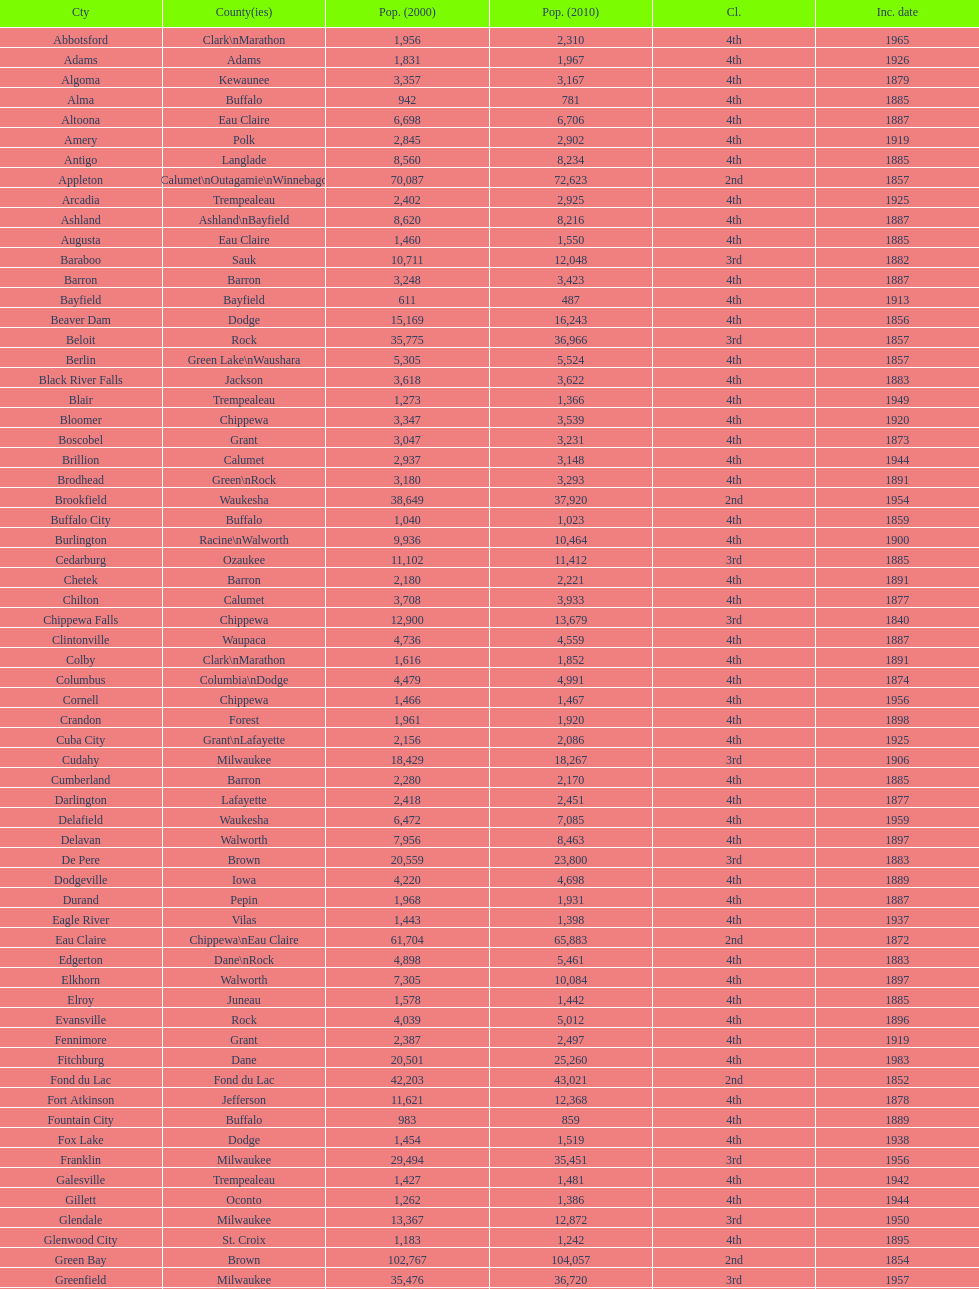Could you parse the entire table? {'header': ['Cty', 'County(ies)', 'Pop. (2000)', 'Pop. (2010)', 'Cl.', 'Inc. date'], 'rows': [['Abbotsford', 'Clark\\nMarathon', '1,956', '2,310', '4th', '1965'], ['Adams', 'Adams', '1,831', '1,967', '4th', '1926'], ['Algoma', 'Kewaunee', '3,357', '3,167', '4th', '1879'], ['Alma', 'Buffalo', '942', '781', '4th', '1885'], ['Altoona', 'Eau Claire', '6,698', '6,706', '4th', '1887'], ['Amery', 'Polk', '2,845', '2,902', '4th', '1919'], ['Antigo', 'Langlade', '8,560', '8,234', '4th', '1885'], ['Appleton', 'Calumet\\nOutagamie\\nWinnebago', '70,087', '72,623', '2nd', '1857'], ['Arcadia', 'Trempealeau', '2,402', '2,925', '4th', '1925'], ['Ashland', 'Ashland\\nBayfield', '8,620', '8,216', '4th', '1887'], ['Augusta', 'Eau Claire', '1,460', '1,550', '4th', '1885'], ['Baraboo', 'Sauk', '10,711', '12,048', '3rd', '1882'], ['Barron', 'Barron', '3,248', '3,423', '4th', '1887'], ['Bayfield', 'Bayfield', '611', '487', '4th', '1913'], ['Beaver Dam', 'Dodge', '15,169', '16,243', '4th', '1856'], ['Beloit', 'Rock', '35,775', '36,966', '3rd', '1857'], ['Berlin', 'Green Lake\\nWaushara', '5,305', '5,524', '4th', '1857'], ['Black River Falls', 'Jackson', '3,618', '3,622', '4th', '1883'], ['Blair', 'Trempealeau', '1,273', '1,366', '4th', '1949'], ['Bloomer', 'Chippewa', '3,347', '3,539', '4th', '1920'], ['Boscobel', 'Grant', '3,047', '3,231', '4th', '1873'], ['Brillion', 'Calumet', '2,937', '3,148', '4th', '1944'], ['Brodhead', 'Green\\nRock', '3,180', '3,293', '4th', '1891'], ['Brookfield', 'Waukesha', '38,649', '37,920', '2nd', '1954'], ['Buffalo City', 'Buffalo', '1,040', '1,023', '4th', '1859'], ['Burlington', 'Racine\\nWalworth', '9,936', '10,464', '4th', '1900'], ['Cedarburg', 'Ozaukee', '11,102', '11,412', '3rd', '1885'], ['Chetek', 'Barron', '2,180', '2,221', '4th', '1891'], ['Chilton', 'Calumet', '3,708', '3,933', '4th', '1877'], ['Chippewa Falls', 'Chippewa', '12,900', '13,679', '3rd', '1840'], ['Clintonville', 'Waupaca', '4,736', '4,559', '4th', '1887'], ['Colby', 'Clark\\nMarathon', '1,616', '1,852', '4th', '1891'], ['Columbus', 'Columbia\\nDodge', '4,479', '4,991', '4th', '1874'], ['Cornell', 'Chippewa', '1,466', '1,467', '4th', '1956'], ['Crandon', 'Forest', '1,961', '1,920', '4th', '1898'], ['Cuba City', 'Grant\\nLafayette', '2,156', '2,086', '4th', '1925'], ['Cudahy', 'Milwaukee', '18,429', '18,267', '3rd', '1906'], ['Cumberland', 'Barron', '2,280', '2,170', '4th', '1885'], ['Darlington', 'Lafayette', '2,418', '2,451', '4th', '1877'], ['Delafield', 'Waukesha', '6,472', '7,085', '4th', '1959'], ['Delavan', 'Walworth', '7,956', '8,463', '4th', '1897'], ['De Pere', 'Brown', '20,559', '23,800', '3rd', '1883'], ['Dodgeville', 'Iowa', '4,220', '4,698', '4th', '1889'], ['Durand', 'Pepin', '1,968', '1,931', '4th', '1887'], ['Eagle River', 'Vilas', '1,443', '1,398', '4th', '1937'], ['Eau Claire', 'Chippewa\\nEau Claire', '61,704', '65,883', '2nd', '1872'], ['Edgerton', 'Dane\\nRock', '4,898', '5,461', '4th', '1883'], ['Elkhorn', 'Walworth', '7,305', '10,084', '4th', '1897'], ['Elroy', 'Juneau', '1,578', '1,442', '4th', '1885'], ['Evansville', 'Rock', '4,039', '5,012', '4th', '1896'], ['Fennimore', 'Grant', '2,387', '2,497', '4th', '1919'], ['Fitchburg', 'Dane', '20,501', '25,260', '4th', '1983'], ['Fond du Lac', 'Fond du Lac', '42,203', '43,021', '2nd', '1852'], ['Fort Atkinson', 'Jefferson', '11,621', '12,368', '4th', '1878'], ['Fountain City', 'Buffalo', '983', '859', '4th', '1889'], ['Fox Lake', 'Dodge', '1,454', '1,519', '4th', '1938'], ['Franklin', 'Milwaukee', '29,494', '35,451', '3rd', '1956'], ['Galesville', 'Trempealeau', '1,427', '1,481', '4th', '1942'], ['Gillett', 'Oconto', '1,262', '1,386', '4th', '1944'], ['Glendale', 'Milwaukee', '13,367', '12,872', '3rd', '1950'], ['Glenwood City', 'St. Croix', '1,183', '1,242', '4th', '1895'], ['Green Bay', 'Brown', '102,767', '104,057', '2nd', '1854'], ['Greenfield', 'Milwaukee', '35,476', '36,720', '3rd', '1957'], ['Green Lake', 'Green Lake', '1,100', '960', '4th', '1962'], ['Greenwood', 'Clark', '1,079', '1,026', '4th', '1891'], ['Hartford', 'Dodge\\nWashington', '10,905', '14,223', '3rd', '1883'], ['Hayward', 'Sawyer', '2,129', '2,318', '4th', '1915'], ['Hillsboro', 'Vernon', '1,302', '1,417', '4th', '1885'], ['Horicon', 'Dodge', '3,775', '3,655', '4th', '1897'], ['Hudson', 'St. Croix', '8,775', '12,719', '4th', '1858'], ['Hurley', 'Iron', '1,818', '1,547', '4th', '1918'], ['Independence', 'Trempealeau', '1,244', '1,336', '4th', '1942'], ['Janesville', 'Rock', '59,498', '63,575', '2nd', '1853'], ['Jefferson', 'Jefferson', '7,338', '7,973', '4th', '1878'], ['Juneau', 'Dodge', '2,485', '2,814', '4th', '1887'], ['Kaukauna', 'Outagamie', '12,983', '15,462', '3rd', '1885'], ['Kenosha', 'Kenosha', '90,352', '99,218', '2nd', '1850'], ['Kewaunee', 'Kewaunee', '2,806', '2,952', '4th', '1883'], ['Kiel', 'Calumet\\nManitowoc', '3,450', '3,738', '4th', '1920'], ['La Crosse', 'La Crosse', '51,818', '51,320', '2nd', '1856'], ['Ladysmith', 'Rusk', '3,932', '3,414', '4th', '1905'], ['Lake Geneva', 'Walworth', '7,148', '7,651', '4th', '1883'], ['Lake Mills', 'Jefferson', '4,843', '5,708', '4th', '1905'], ['Lancaster', 'Grant', '4,070', '3,868', '4th', '1878'], ['Lodi', 'Columbia', '2,882', '3,050', '4th', '1941'], ['Loyal', 'Clark', '1,308', '1,261', '4th', '1948'], ['Madison', 'Dane', '208,054', '233,209', '2nd', '1856'], ['Manawa', 'Waupaca', '1,330', '1,371', '4th', '1954'], ['Manitowoc', 'Manitowoc', '34,053', '33,736', '3rd', '1870'], ['Marinette', 'Marinette', '11,749', '10,968', '3rd', '1887'], ['Marion', 'Shawano\\nWaupaca', '1,297', '1,260', '4th', '1898'], ['Markesan', 'Green Lake', '1,396', '1,476', '4th', '1959'], ['Marshfield', 'Marathon\\nWood', '18,800', '19,118', '3rd', '1883'], ['Mauston', 'Juneau', '3,740', '4,423', '4th', '1883'], ['Mayville', 'Dodge', '4,902', '5,154', '4th', '1885'], ['Medford', 'Taylor', '4,350', '4,326', '4th', '1889'], ['Mellen', 'Ashland', '845', '731', '4th', '1907'], ['Menasha', 'Calumet\\nWinnebago', '16,331', '17,353', '3rd', '1874'], ['Menomonie', 'Dunn', '14,937', '16,264', '4th', '1882'], ['Mequon', 'Ozaukee', '22,643', '23,132', '4th', '1957'], ['Merrill', 'Lincoln', '10,146', '9,661', '4th', '1883'], ['Middleton', 'Dane', '15,770', '17,442', '3rd', '1963'], ['Milton', 'Rock', '5,132', '5,546', '4th', '1969'], ['Milwaukee', 'Milwaukee\\nWashington\\nWaukesha', '596,974', '594,833', '1st', '1846'], ['Mineral Point', 'Iowa', '2,617', '2,487', '4th', '1857'], ['Mondovi', 'Buffalo', '2,634', '2,777', '4th', '1889'], ['Monona', 'Dane', '8,018', '7,533', '4th', '1969'], ['Monroe', 'Green', '10,843', '10,827', '4th', '1882'], ['Montello', 'Marquette', '1,397', '1,495', '4th', '1938'], ['Montreal', 'Iron', '838', '807', '4th', '1924'], ['Mosinee', 'Marathon', '4,063', '3,988', '4th', '1931'], ['Muskego', 'Waukesha', '21,397', '24,135', '3rd', '1964'], ['Neenah', 'Winnebago', '24,507', '25,501', '3rd', '1873'], ['Neillsville', 'Clark', '2,731', '2,463', '4th', '1882'], ['Nekoosa', 'Wood', '2,590', '2,580', '4th', '1926'], ['New Berlin', 'Waukesha', '38,220', '39,584', '3rd', '1959'], ['New Holstein', 'Calumet', '3,301', '3,236', '4th', '1889'], ['New Lisbon', 'Juneau', '1,436', '2,554', '4th', '1889'], ['New London', 'Outagamie\\nWaupaca', '7,085', '7,295', '4th', '1877'], ['New Richmond', 'St. Croix', '6,310', '8,375', '4th', '1885'], ['Niagara', 'Marinette', '1,880', '1,624', '4th', '1992'], ['Oak Creek', 'Milwaukee', '28,456', '34,451', '3rd', '1955'], ['Oconomowoc', 'Waukesha', '12,382', '15,712', '3rd', '1875'], ['Oconto', 'Oconto', '4,708', '4,513', '4th', '1869'], ['Oconto Falls', 'Oconto', '2,843', '2,891', '4th', '1919'], ['Omro', 'Winnebago', '3,177', '3,517', '4th', '1944'], ['Onalaska', 'La Crosse', '14,839', '17,736', '4th', '1887'], ['Oshkosh', 'Winnebago', '62,916', '66,083', '2nd', '1853'], ['Osseo', 'Trempealeau', '1,669', '1,701', '4th', '1941'], ['Owen', 'Clark', '936', '940', '4th', '1925'], ['Park Falls', 'Price', '2,739', '2,462', '4th', '1912'], ['Peshtigo', 'Marinette', '3,474', '3,502', '4th', '1903'], ['Pewaukee', 'Waukesha', '11,783', '13,195', '3rd', '1999'], ['Phillips', 'Price', '1,675', '1,478', '4th', '1891'], ['Pittsville', 'Wood', '866', '874', '4th', '1887'], ['Platteville', 'Grant', '9,989', '11,224', '4th', '1876'], ['Plymouth', 'Sheboygan', '7,781', '8,445', '4th', '1877'], ['Port Washington', 'Ozaukee', '10,467', '11,250', '4th', '1882'], ['Portage', 'Columbia', '9,728', '10,324', '4th', '1854'], ['Prairie du Chien', 'Crawford', '6,018', '5,911', '4th', '1872'], ['Prescott', 'Pierce', '3,764', '4,258', '4th', '1857'], ['Princeton', 'Green Lake', '1,504', '1,214', '4th', '1920'], ['Racine', 'Racine', '81,855', '78,860', '2nd', '1848'], ['Reedsburg', 'Sauk', '7,827', '10,014', '4th', '1887'], ['Rhinelander', 'Oneida', '7,735', '7,798', '4th', '1894'], ['Rice Lake', 'Barron', '8,312', '8,438', '4th', '1887'], ['Richland Center', 'Richland', '5,114', '5,184', '4th', '1887'], ['Ripon', 'Fond du Lac', '7,450', '7,733', '4th', '1858'], ['River Falls', 'Pierce\\nSt. Croix', '12,560', '15,000', '3rd', '1875'], ['St. Croix Falls', 'Polk', '2,033', '2,133', '4th', '1958'], ['St. Francis', 'Milwaukee', '8,662', '9,365', '4th', '1951'], ['Schofield', 'Marathon', '2,117', '2,169', '4th', '1951'], ['Seymour', 'Outagamie', '3,335', '3,451', '4th', '1879'], ['Shawano', 'Shawano', '8,298', '9,305', '4th', '1874'], ['Sheboygan', 'Sheboygan', '50,792', '49,288', '2nd', '1853'], ['Sheboygan Falls', 'Sheboygan', '6,772', '7,775', '4th', '1913'], ['Shell Lake', 'Washburn', '1,309', '1,347', '4th', '1961'], ['Shullsburg', 'Lafayette', '1,246', '1,226', '4th', '1889'], ['South Milwaukee', 'Milwaukee', '21,256', '21,156', '4th', '1897'], ['Sparta', 'Monroe', '8,648', '9,522', '4th', '1883'], ['Spooner', 'Washburn', '2,653', '2,682', '4th', '1909'], ['Stanley', 'Chippewa\\nClark', '1,898', '3,608', '4th', '1898'], ['Stevens Point', 'Portage', '24,551', '26,717', '3rd', '1858'], ['Stoughton', 'Dane', '12,354', '12,611', '4th', '1882'], ['Sturgeon Bay', 'Door', '9,437', '9,144', '4th', '1883'], ['Sun Prairie', 'Dane', '20,369', '29,364', '3rd', '1958'], ['Superior', 'Douglas', '27,368', '27,244', '2nd', '1858'], ['Thorp', 'Clark', '1,536', '1,621', '4th', '1948'], ['Tomah', 'Monroe', '8,419', '9,093', '4th', '1883'], ['Tomahawk', 'Lincoln', '3,770', '3,397', '4th', '1891'], ['Two Rivers', 'Manitowoc', '12,639', '11,712', '3rd', '1878'], ['Verona', 'Dane', '7,052', '10,619', '4th', '1977'], ['Viroqua', 'Vernon', '4,335', '5,079', '4th', '1885'], ['Washburn', 'Bayfield', '2,280', '2,117', '4th', '1904'], ['Waterloo', 'Jefferson', '3,259', '3,333', '4th', '1962'], ['Watertown', 'Dodge\\nJefferson', '21,598', '23,861', '3rd', '1853'], ['Waukesha', 'Waukesha', '64,825', '70,718', '2nd', '1895'], ['Waupaca', 'Waupaca', '5,676', '6,069', '4th', '1878'], ['Waupun', 'Dodge\\nFond du Lac', '10,944', '11,340', '4th', '1878'], ['Wausau', 'Marathon', '38,426', '39,106', '3rd', '1872'], ['Wautoma', 'Waushara', '1,998', '2,218', '4th', '1901'], ['Wauwatosa', 'Milwaukee', '47,271', '46,396', '2nd', '1897'], ['West Allis', 'Milwaukee', '61,254', '60,411', '2nd', '1906'], ['West Bend', 'Washington', '28,152', '31,078', '3rd', '1885'], ['Westby', 'Vernon', '2,045', '2,200', '4th', '1920'], ['Weyauwega', 'Waupaca', '1,806', '1,900', '4th', '1939'], ['Whitehall', 'Trempealeau', '1,651', '1,558', '4th', '1941'], ['Whitewater', 'Jefferson\\nWalworth', '13,437', '14,390', '4th', '1885'], ['Wisconsin Dells', 'Adams\\nColumbia\\nJuneau\\nSauk', '2,418', '2,678', '4th', '1925'], ['Wisconsin Rapids', 'Wood', '18,435', '18,367', '3rd', '1869']]} How many cities have 1926 as their incorporation date? 2. 